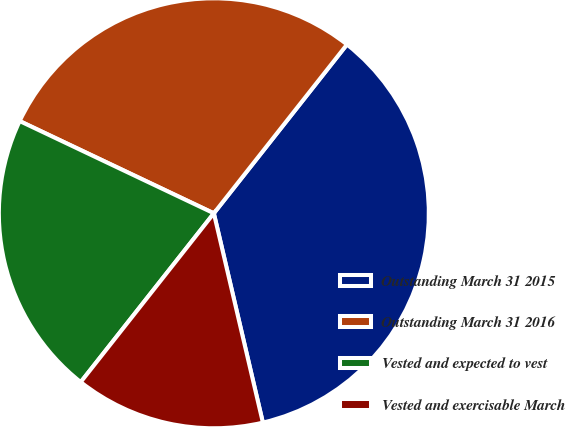Convert chart. <chart><loc_0><loc_0><loc_500><loc_500><pie_chart><fcel>Outstanding March 31 2015<fcel>Outstanding March 31 2016<fcel>Vested and expected to vest<fcel>Vested and exercisable March<nl><fcel>35.71%<fcel>28.57%<fcel>21.43%<fcel>14.29%<nl></chart> 